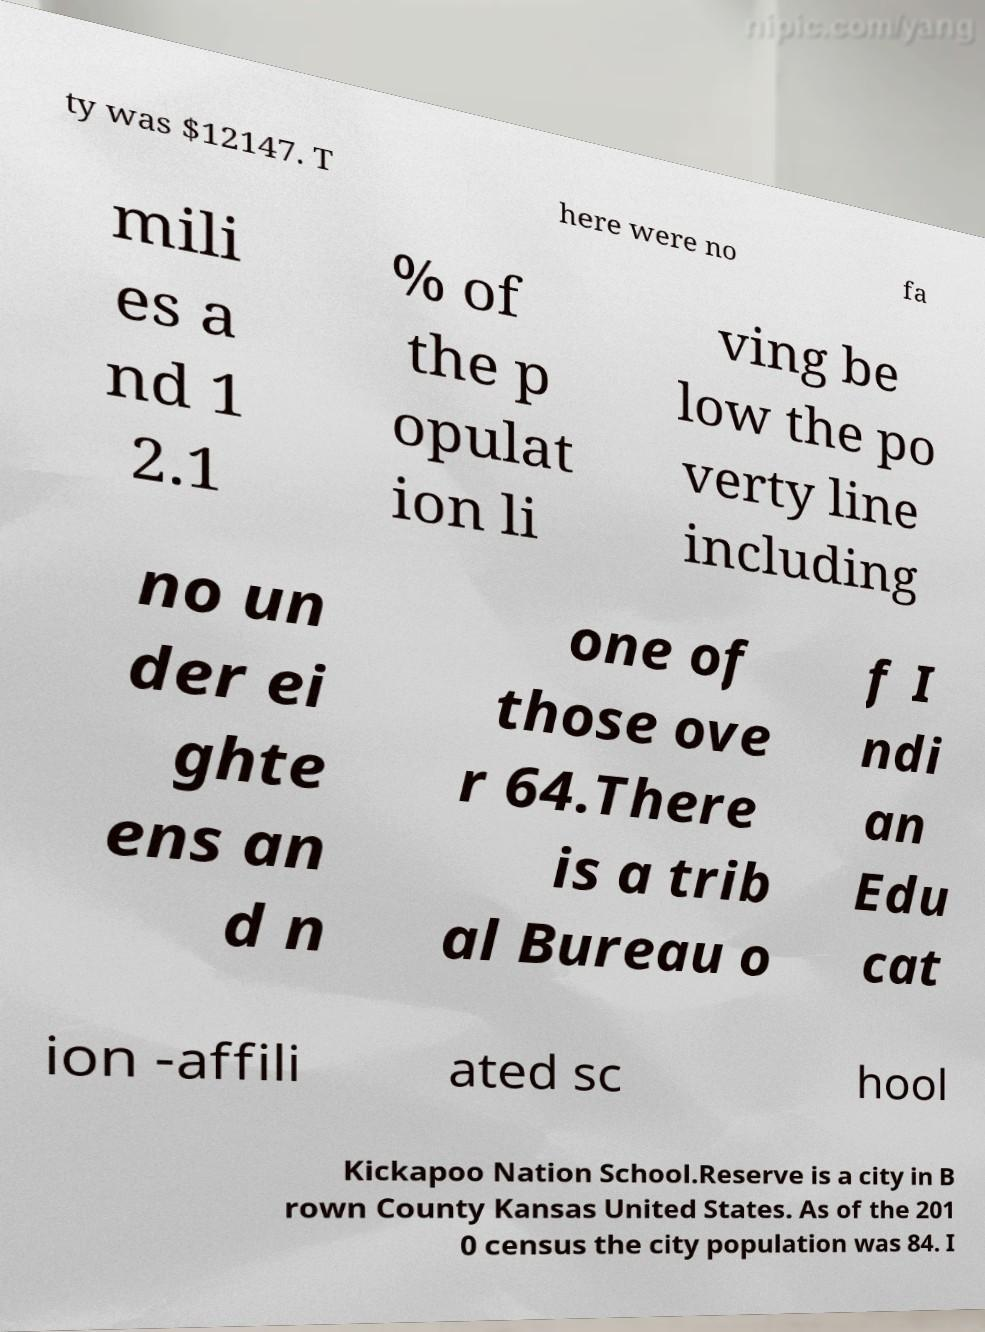Can you accurately transcribe the text from the provided image for me? ty was $12147. T here were no fa mili es a nd 1 2.1 % of the p opulat ion li ving be low the po verty line including no un der ei ghte ens an d n one of those ove r 64.There is a trib al Bureau o f I ndi an Edu cat ion -affili ated sc hool Kickapoo Nation School.Reserve is a city in B rown County Kansas United States. As of the 201 0 census the city population was 84. I 